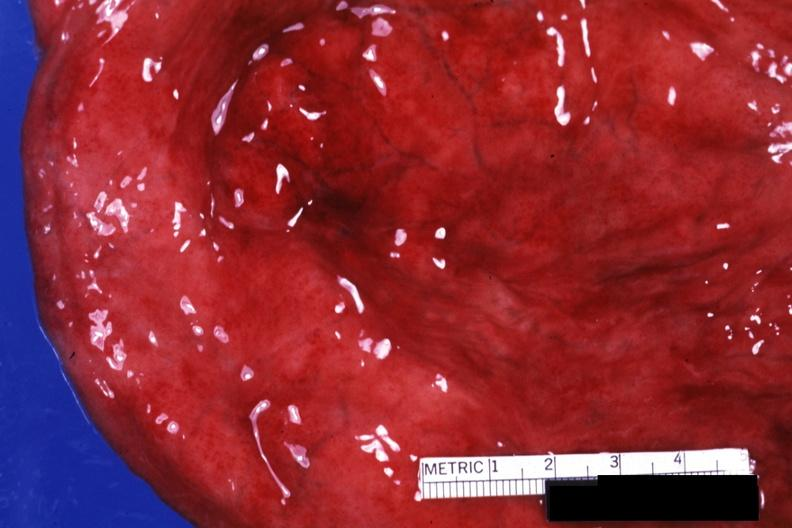s suture granuloma present?
Answer the question using a single word or phrase. No 